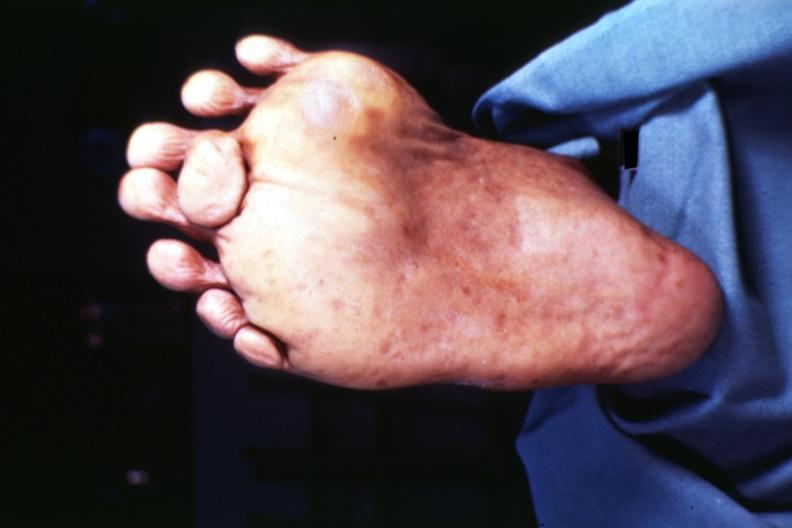what are present?
Answer the question using a single word or phrase. Extremities 